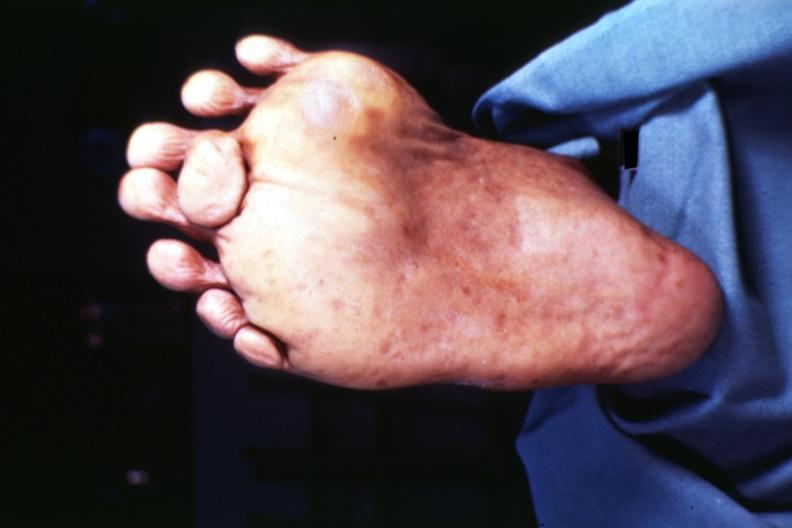what are present?
Answer the question using a single word or phrase. Extremities 